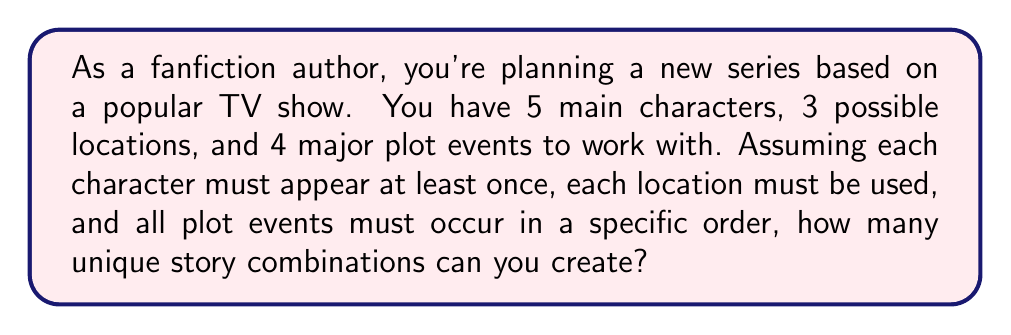Teach me how to tackle this problem. Let's break this down step-by-step:

1) First, we need to consider the character appearances. Each character must appear at least once, but can appear multiple times. This is equivalent to distributing the characters among the events with repetition allowed. The number of ways to do this is:

   $${5 + 4 - 1 \choose 4} = {8 \choose 4} = 70$$

2) Next, we need to assign locations to each event. We have 3 locations and 4 events, and each location must be used at least once. This is a surjective function from events to locations. The number of such functions is given by:

   $$3! \cdot S(4,3) = 6 \cdot 6 = 36$$

   Where $S(4,3)$ is the Stirling number of the second kind.

3) The plot events must occur in a specific order, so there's only 1 way to arrange them.

4) By the multiplication principle, the total number of unique story combinations is:

   $$70 \cdot 36 \cdot 1 = 2520$$

Therefore, you can create 2520 unique story combinations with these elements.
Answer: 2520 